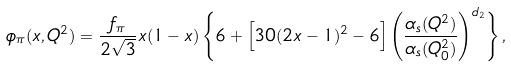Convert formula to latex. <formula><loc_0><loc_0><loc_500><loc_500>\phi _ { \pi } ( x , Q ^ { 2 } ) = \frac { f _ { \pi } } { 2 \sqrt { 3 } } x ( 1 - x ) \left \{ 6 + \left [ 3 0 ( 2 x - 1 ) ^ { 2 } - 6 \right ] \left ( \frac { \alpha _ { s } ( Q ^ { 2 } ) } { \alpha _ { s } ( Q _ { 0 } ^ { 2 } ) } \right ) ^ { d _ { 2 } } \right \} ,</formula> 